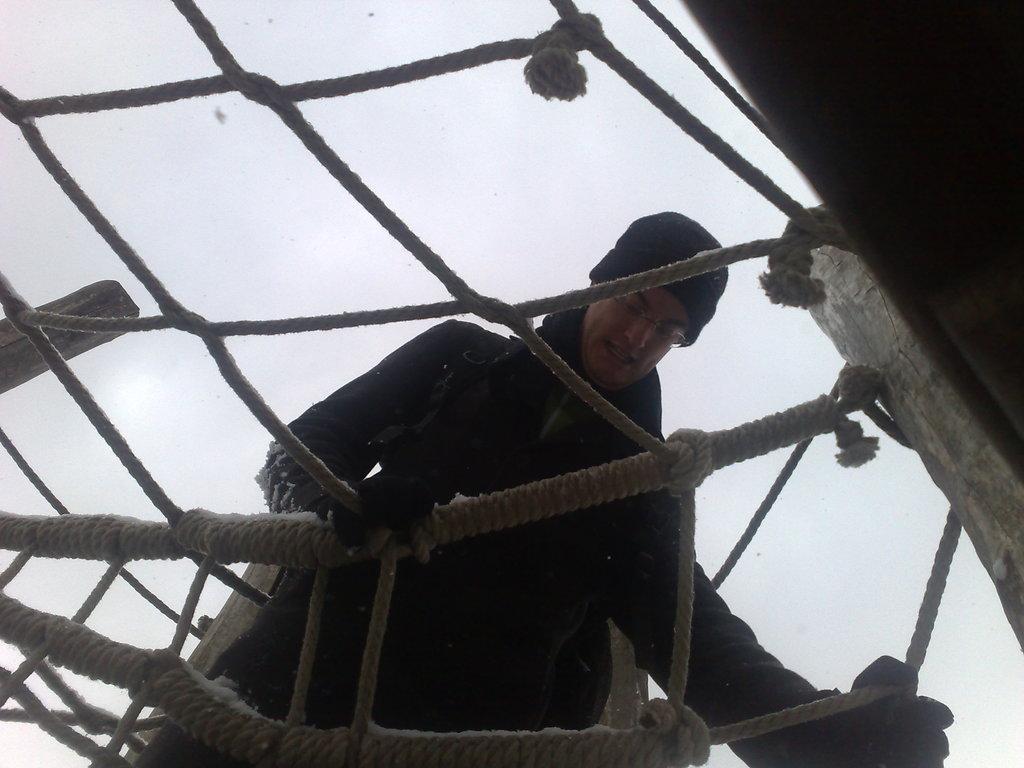In one or two sentences, can you explain what this image depicts? There is a person in a coat walking on the net which is made with threads and there are connected with poles. In the background, there is sky. 